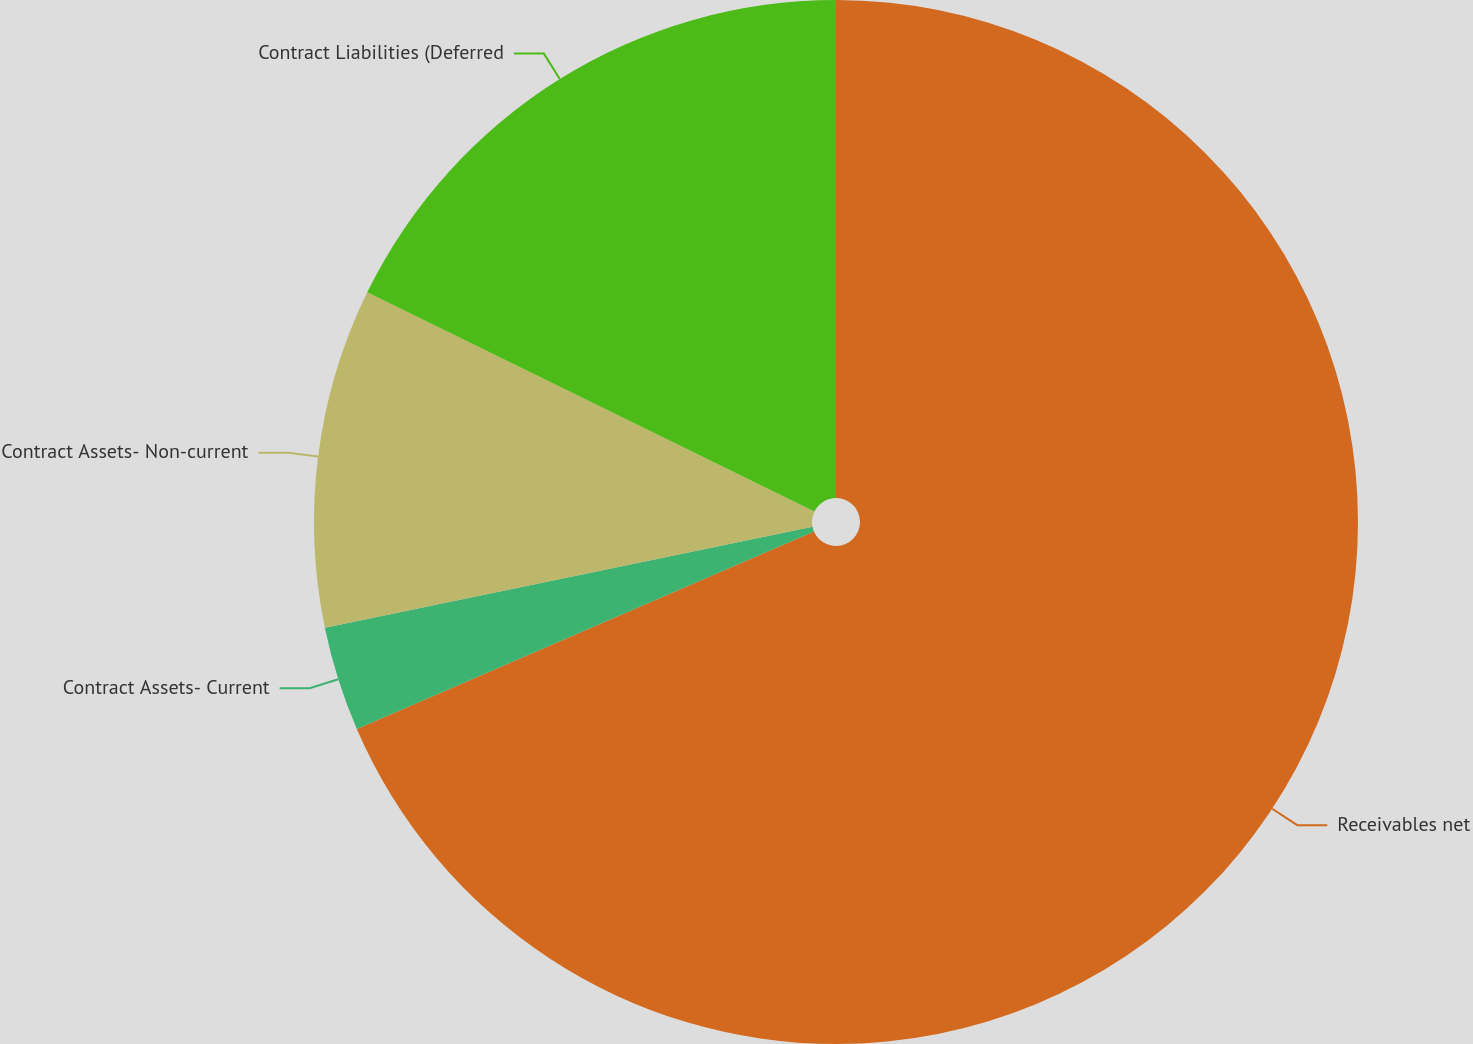Convert chart to OTSL. <chart><loc_0><loc_0><loc_500><loc_500><pie_chart><fcel>Receivables net<fcel>Contract Assets- Current<fcel>Contract Assets- Non-current<fcel>Contract Liabilities (Deferred<nl><fcel>68.51%<fcel>3.24%<fcel>10.5%<fcel>17.75%<nl></chart> 